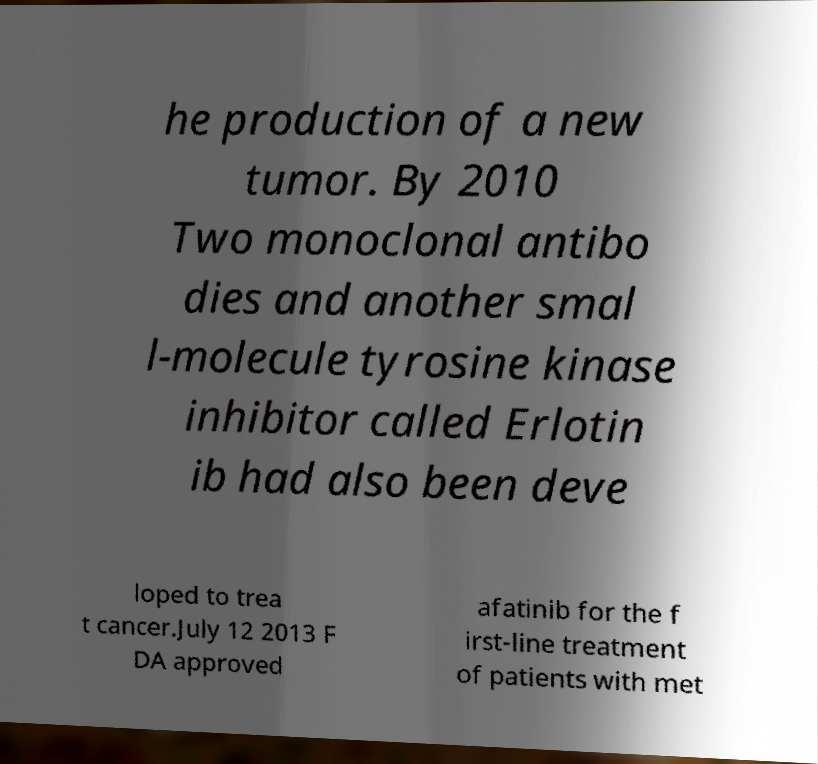For documentation purposes, I need the text within this image transcribed. Could you provide that? he production of a new tumor. By 2010 Two monoclonal antibo dies and another smal l-molecule tyrosine kinase inhibitor called Erlotin ib had also been deve loped to trea t cancer.July 12 2013 F DA approved afatinib for the f irst-line treatment of patients with met 